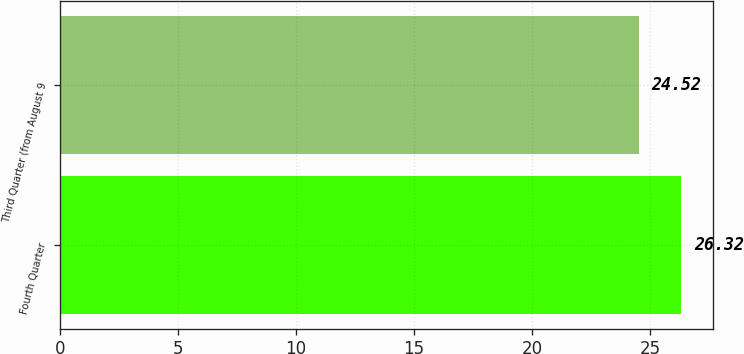<chart> <loc_0><loc_0><loc_500><loc_500><bar_chart><fcel>Fourth Quarter<fcel>Third Quarter (from August 9<nl><fcel>26.32<fcel>24.52<nl></chart> 